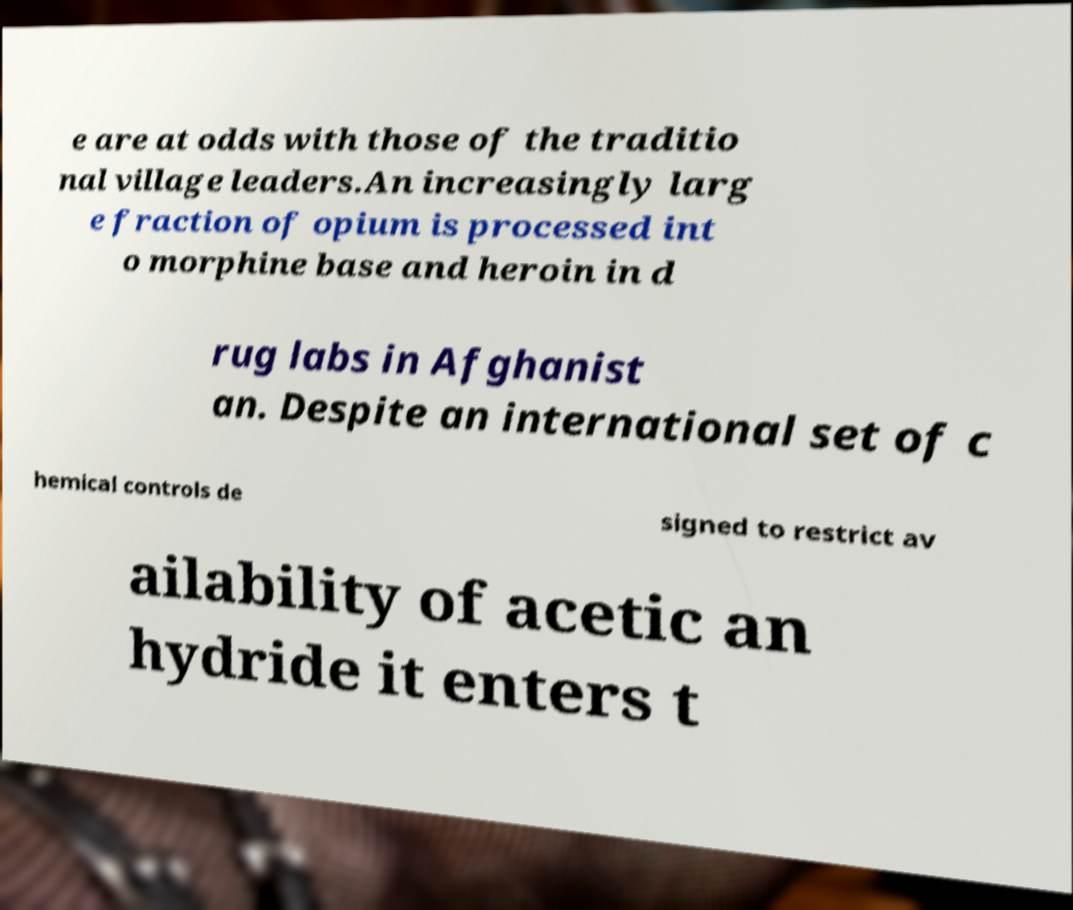Could you assist in decoding the text presented in this image and type it out clearly? e are at odds with those of the traditio nal village leaders.An increasingly larg e fraction of opium is processed int o morphine base and heroin in d rug labs in Afghanist an. Despite an international set of c hemical controls de signed to restrict av ailability of acetic an hydride it enters t 